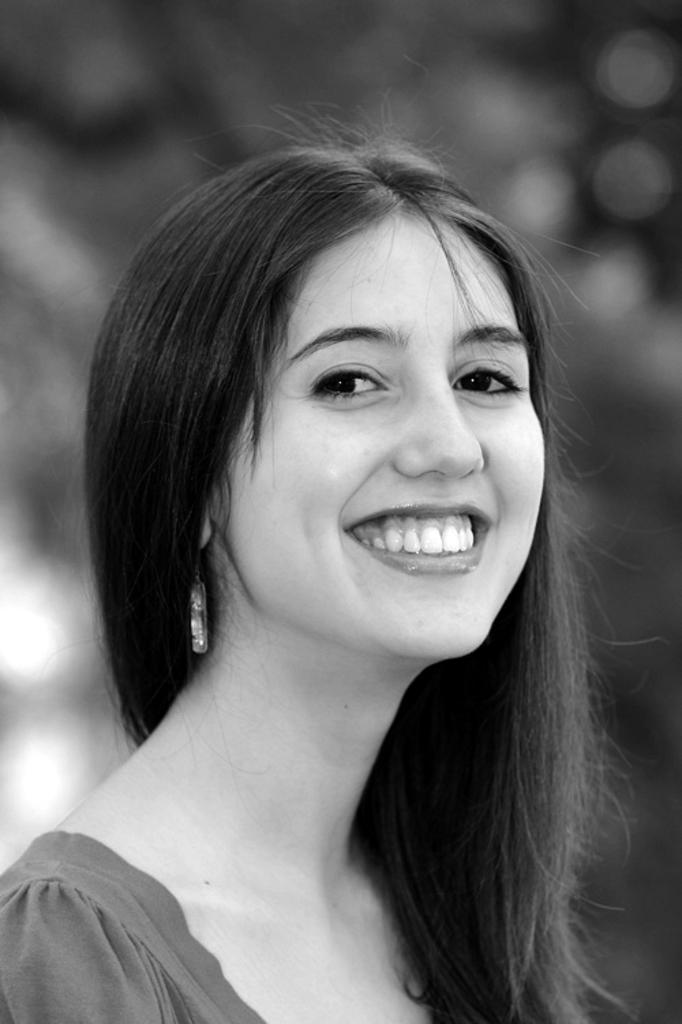Who is present in the image? There is a woman in the image. Can you describe the time of day when the image was likely taken? The image was likely taken during the day. What type of whip can be seen in the woman's mouth in the image? There is no whip present in the woman's mouth or anywhere in the image. 